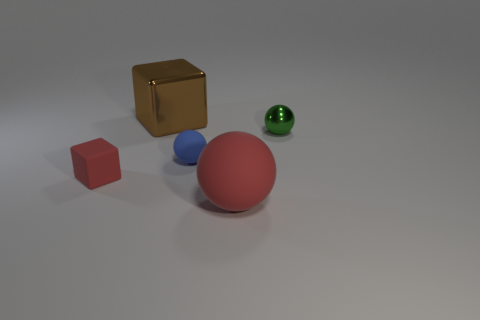Is there any significance to the color choices in this image? Colors can convey a variety of moods and ideas. In this image, the vibrant red hue of the sphere and cube draws the viewer's eye as it stands out from the cooler blue and green tones of the other spheres. The red could symbolize energy or passion, while the blue may impart feelings of calm and serenity. The green sphere offers a sense of growth or harmony, and the gold cube adds an element of luxury or value. The chosen colors could be used to explore color theory, contrast, or simply for aesthetic appeal. 